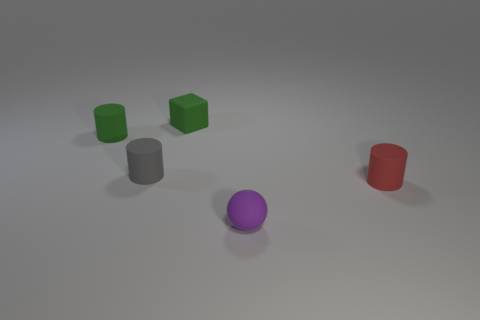Are there fewer green rubber things than rubber cylinders?
Keep it short and to the point. Yes. Do the red cylinder on the right side of the tiny cube and the small green thing behind the tiny green cylinder have the same material?
Provide a short and direct response. Yes. Are there fewer small red objects that are to the right of the tiny red cylinder than matte spheres?
Your answer should be compact. Yes. There is a small rubber object in front of the tiny red cylinder; how many red things are left of it?
Provide a succinct answer. 0. There is a cylinder that is right of the green matte cylinder and to the left of the purple matte object; what is its size?
Offer a very short reply. Small. Are there fewer matte cylinders that are in front of the tiny red matte object than blocks behind the gray matte object?
Provide a succinct answer. Yes. What material is the object on the right side of the purple thing?
Ensure brevity in your answer.  Rubber. There is a tiny rubber object that is right of the tiny green block and behind the purple rubber object; what is its color?
Offer a terse response. Red. What number of other things are there of the same color as the small rubber sphere?
Offer a very short reply. 0. What color is the small thing that is in front of the red rubber cylinder?
Offer a very short reply. Purple. 